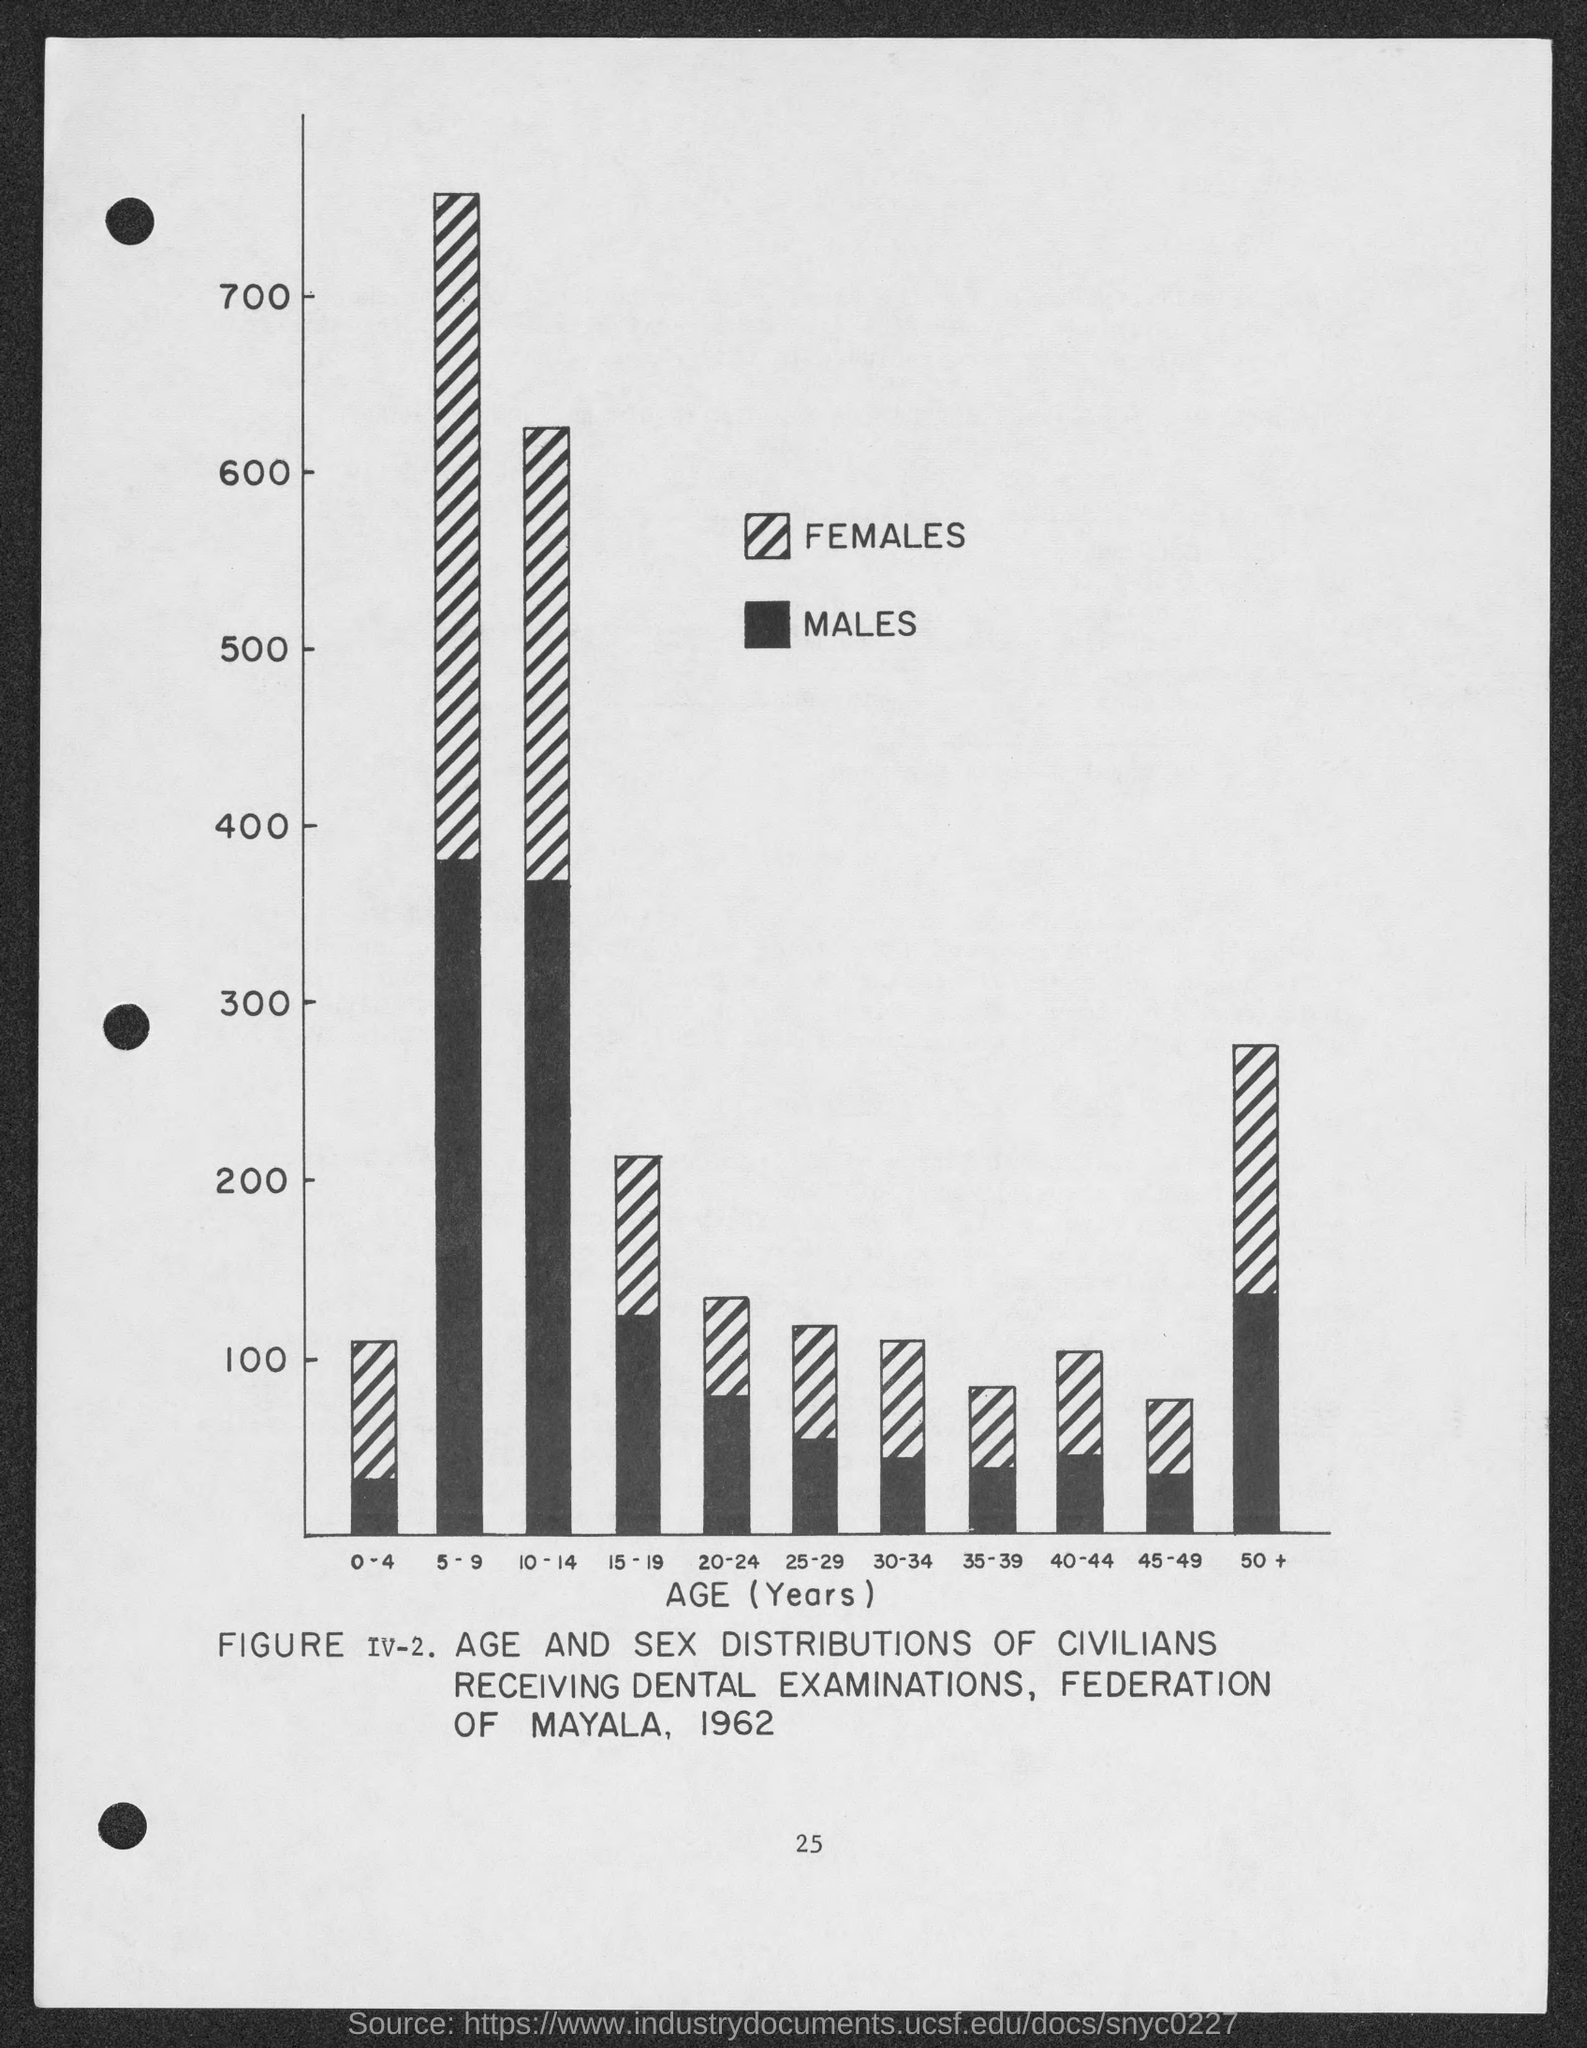Draw attention to some important aspects in this diagram. The number at the bottom of the page is 25. The information provided on the x-axis of the figure is "Age (Years)". 